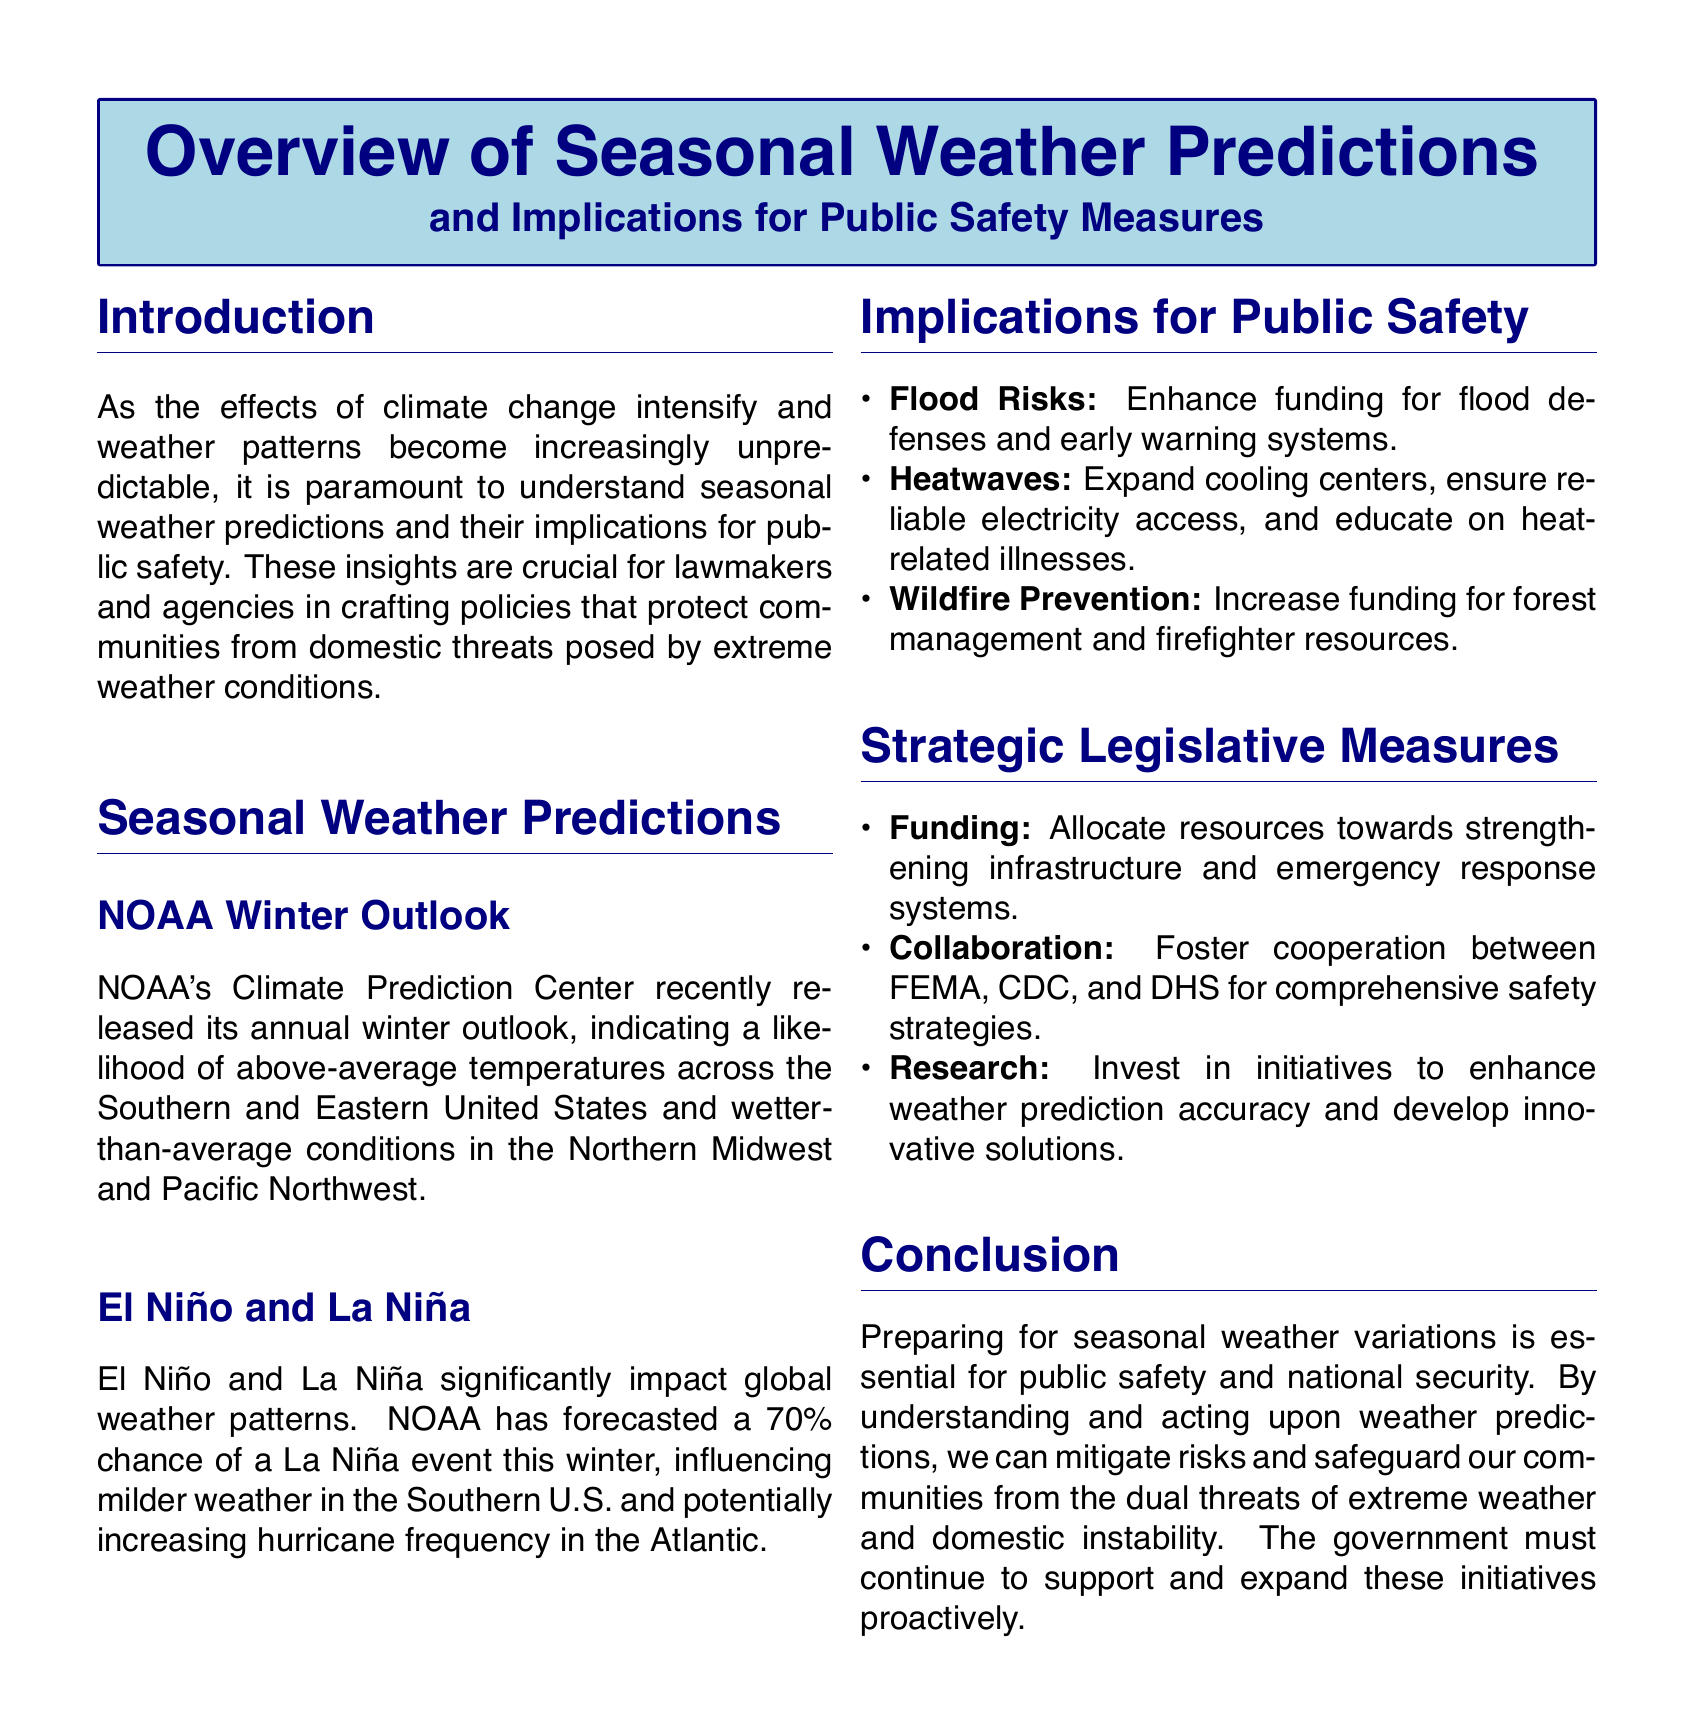What organization released the winter outlook? The document mentions that NOAA's Climate Prediction Center released the winter outlook.
Answer: NOAA What is the predicted temperature trend for the Southern United States? The document states a likelihood of above-average temperatures in the Southern United States.
Answer: Above-average temperatures What percentage chance of a La Niña event is forecasted? The text indicates that there is a 70% chance of a La Niña event this winter.
Answer: 70% What is one necessary action to address flood risks? The document lists enhancing funding for flood defenses and early warning systems as necessary.
Answer: Enhance funding What collaborative approach is suggested in the document? The document advocates for fostering cooperation between FEMA, CDC, and DHS.
Answer: Cooperation between FEMA, CDC, and DHS What phenomena significantly impacts global weather patterns? El Niño and La Niña are mentioned as significant influences on global weather patterns.
Answer: El Niño and La Niña What type of weather is predicted for the Atlantic due to La Niña? The document forecasts that there could be an increase in hurricane frequency in the Atlantic due to La Niña.
Answer: Increase in hurricane frequency What is one key focus for public safety regarding heatwaves? The document suggests expanding cooling centers and ensuring reliable electricity access for heatwave safety.
Answer: Expand cooling centers What is a suggested measure for wildfire prevention? Increasing funding for forest management and firefighter resources is advocated for wildfire prevention.
Answer: Increase funding What is the overall aim of the document? The objective of the document is to prepare for seasonal weather variations to ensure public safety and national security.
Answer: Public safety and national security 